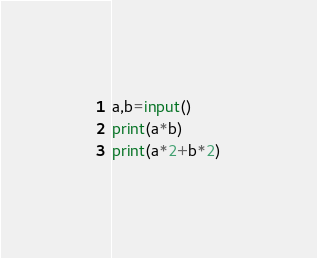<code> <loc_0><loc_0><loc_500><loc_500><_Python_>a,b=input()
print(a*b)
print(a*2+b*2)
</code> 